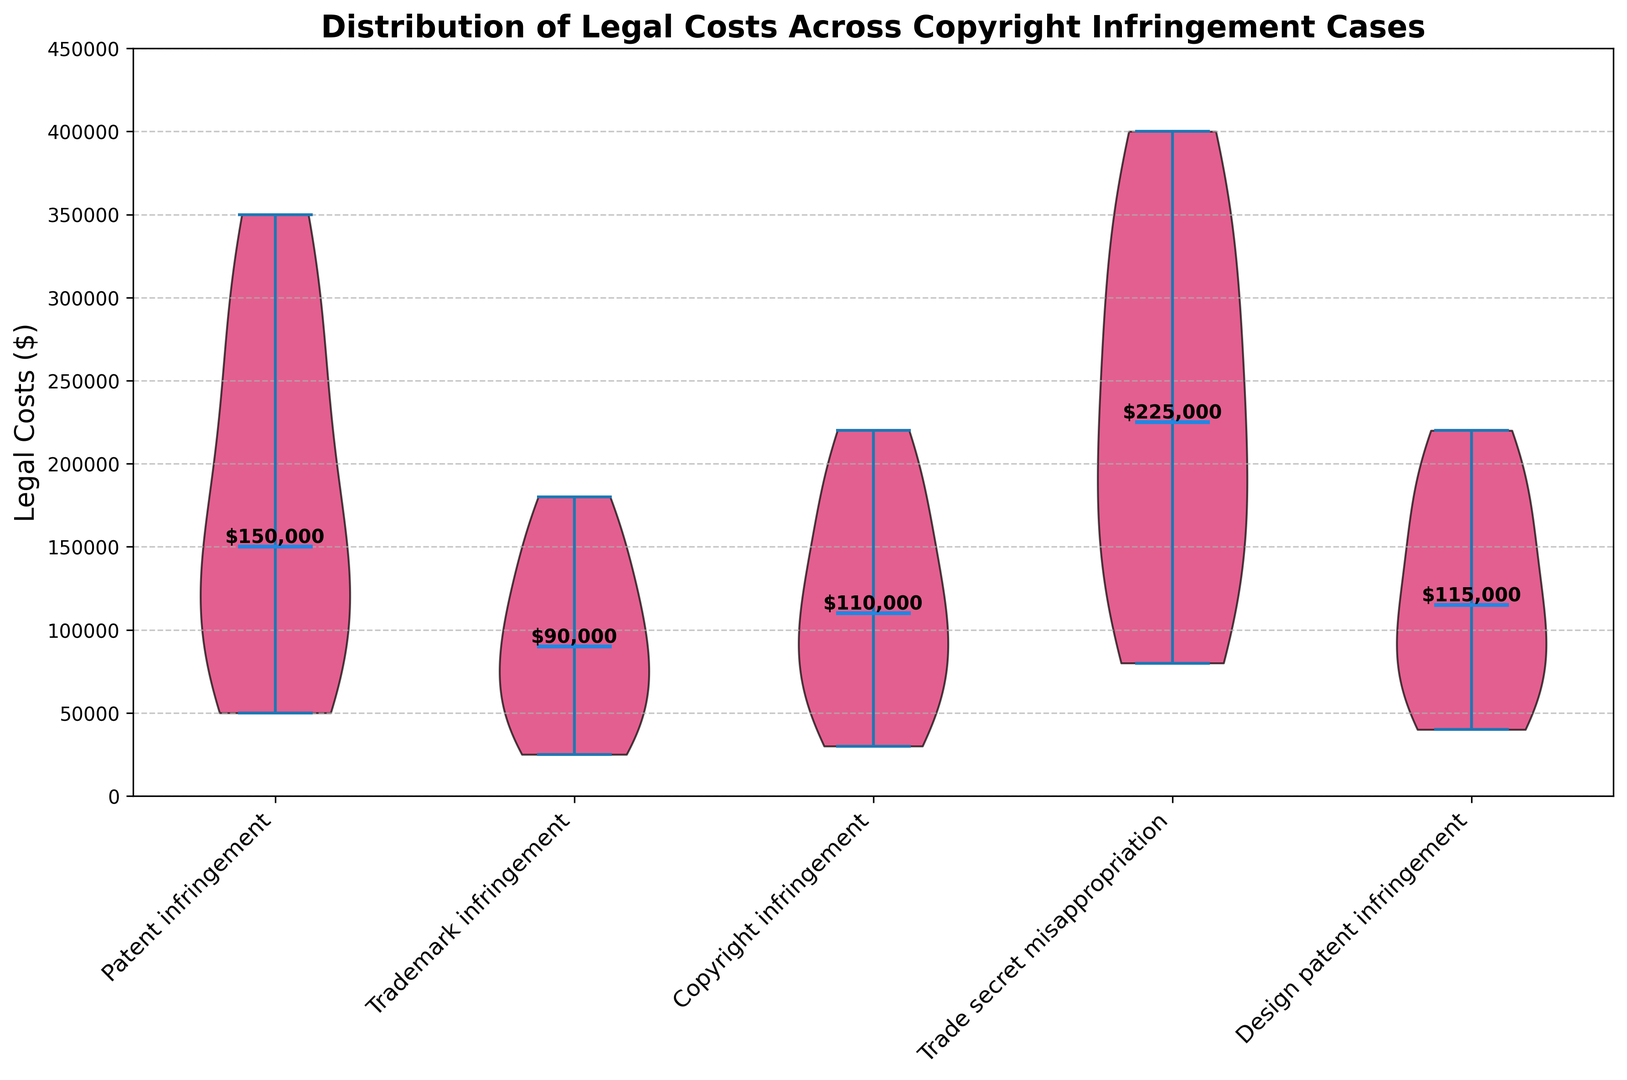What is the median legal cost for patent infringement cases? The median is the middle value when the costs are ordered from lowest to highest. From the plot, identify the median line within the violin for patent infringement and note the value.
Answer: $175,000 What is the range of legal costs for trademark infringement cases? The range is the difference between the maximum and minimum values. For trademark infringement, note the highest and lowest points of the violin and calculate the difference.
Answer: $155,000 Which type of infringement case has the highest median legal cost? Compare the median lines across all violins to find the highest one. From the plot, determine which case type this corresponds to.
Answer: Trade secret misappropriation How do the median legal costs for copyright infringement and design patent infringement compare? Locate the median lines for these two types of cases. Compare their positions to determine which one is higher or lower.
Answer: Copyright infringement < Design patent infringement Which case type shows the widest distribution of legal costs? The widest distribution is represented by the violin with the broadest spread from top to bottom. Identify this case type on the plot.
Answer: Trade secret misappropriation Are legal costs for any type of case consistently above $150,000? Look at the lower bounds of each violin plot and see if there are any violins entirely above the $150,000 mark.
Answer: No What is the visual indication for median legal costs on the plot? Identify how the median costs are visually represented on the violin plot. Note the feature that is used to denote them.
Answer: Blue line in the center of each violin Which infringement case shows the least variability in legal costs? The least variability is indicated by the narrowest violin. Find which case type corresponds to this visual representation.
Answer: Trademark infringement How do the maximum legal costs for patent infringement and copyright infringement compare? Identify the highest points of the violins for both patent infringement and copyright infringement and compare them directly.
Answer: Patent infringement > Copyright infringement What is the color used to represent the violins in the plot? Visually identify the color used to fill the violin plots and describe it.
Answer: Pink 